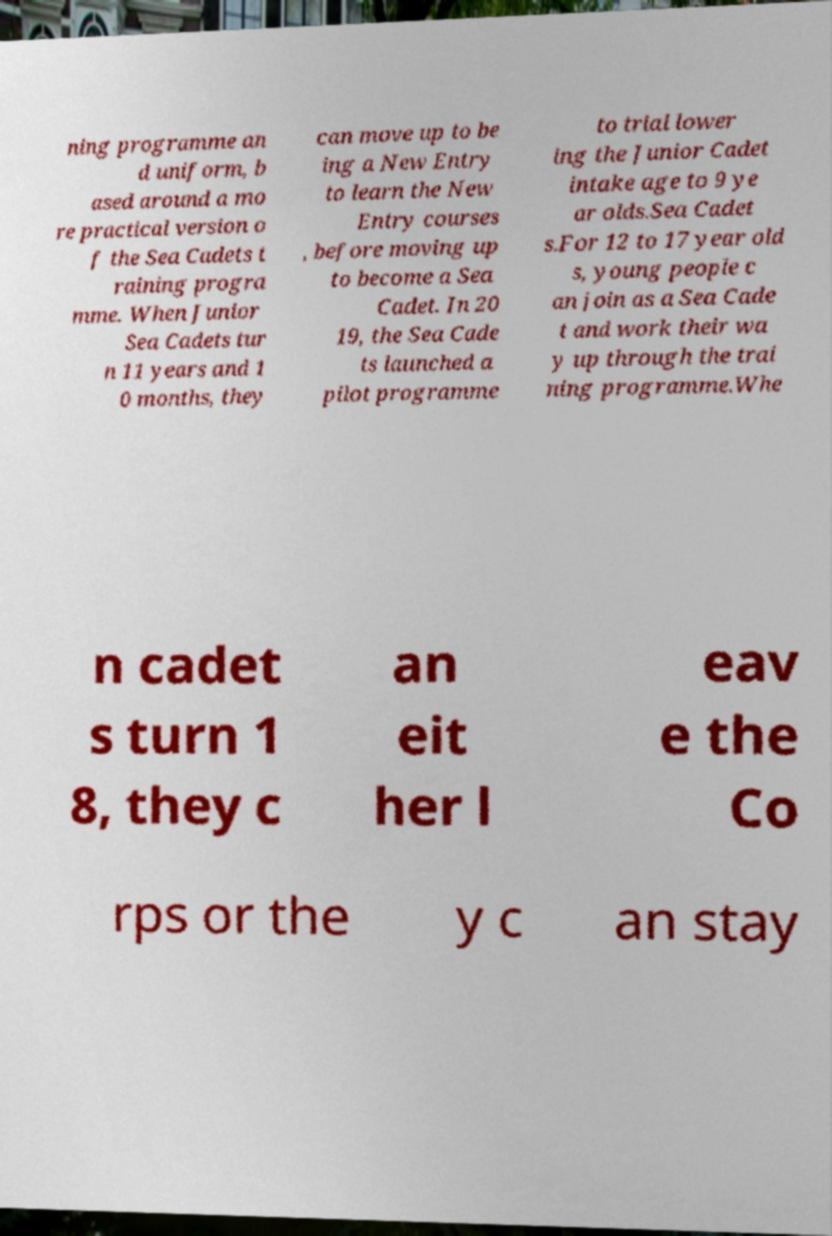Can you accurately transcribe the text from the provided image for me? ning programme an d uniform, b ased around a mo re practical version o f the Sea Cadets t raining progra mme. When Junior Sea Cadets tur n 11 years and 1 0 months, they can move up to be ing a New Entry to learn the New Entry courses , before moving up to become a Sea Cadet. In 20 19, the Sea Cade ts launched a pilot programme to trial lower ing the Junior Cadet intake age to 9 ye ar olds.Sea Cadet s.For 12 to 17 year old s, young people c an join as a Sea Cade t and work their wa y up through the trai ning programme.Whe n cadet s turn 1 8, they c an eit her l eav e the Co rps or the y c an stay 